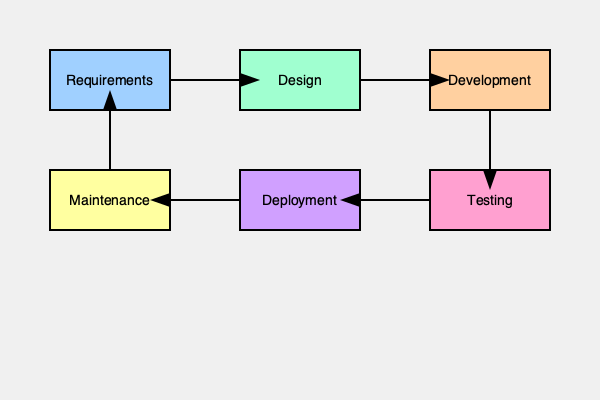In the context of OxyEngine software development, which phase of the lifecycle typically involves integrating the engine's core components and ensuring compatibility with various platforms? To answer this question, let's break down the software development lifecycle for OxyEngine projects:

1. Requirements: In this phase, project managers gather and document the specific needs for the OxyEngine-based project, including features, performance requirements, and target platforms.

2. Design: Here, the system architecture is planned, considering OxyEngine's capabilities and how to best utilize them for the project's needs.

3. Development: This is the phase where the actual coding and integration of OxyEngine components take place. Developers work on:
   a) Integrating OxyEngine's core components into the project
   b) Implementing custom features and gameplay mechanics
   c) Ensuring compatibility with various platforms supported by OxyEngine

4. Testing: The software is rigorously tested to ensure it meets the requirements and functions correctly across all targeted platforms.

5. Deployment: The finished product is released to end-users or submitted to app stores.

6. Maintenance: Ongoing support, bug fixes, and updates are provided post-release.

The phase that specifically involves integrating the engine's core components and ensuring compatibility with various platforms is the Development phase. This is where the actual implementation and integration work occurs, making it the most relevant stage for the described activities.
Answer: Development 